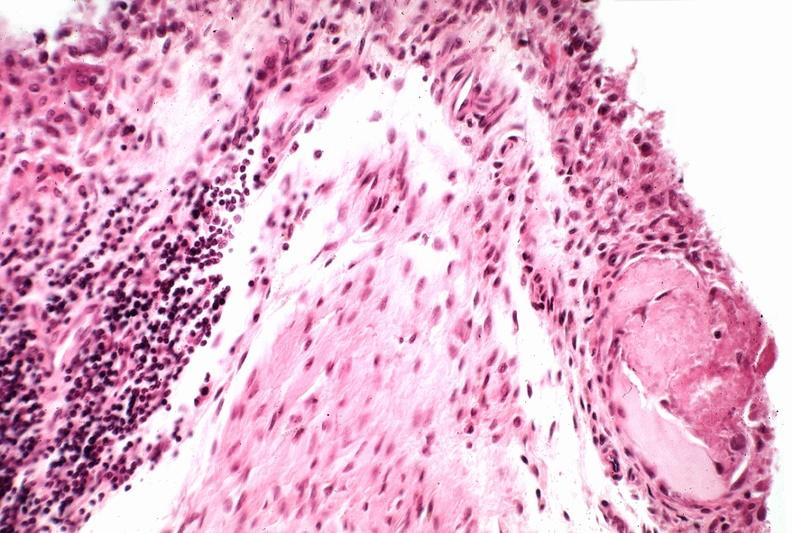s external view of spleen with multiple recent infarcts present?
Answer the question using a single word or phrase. No 